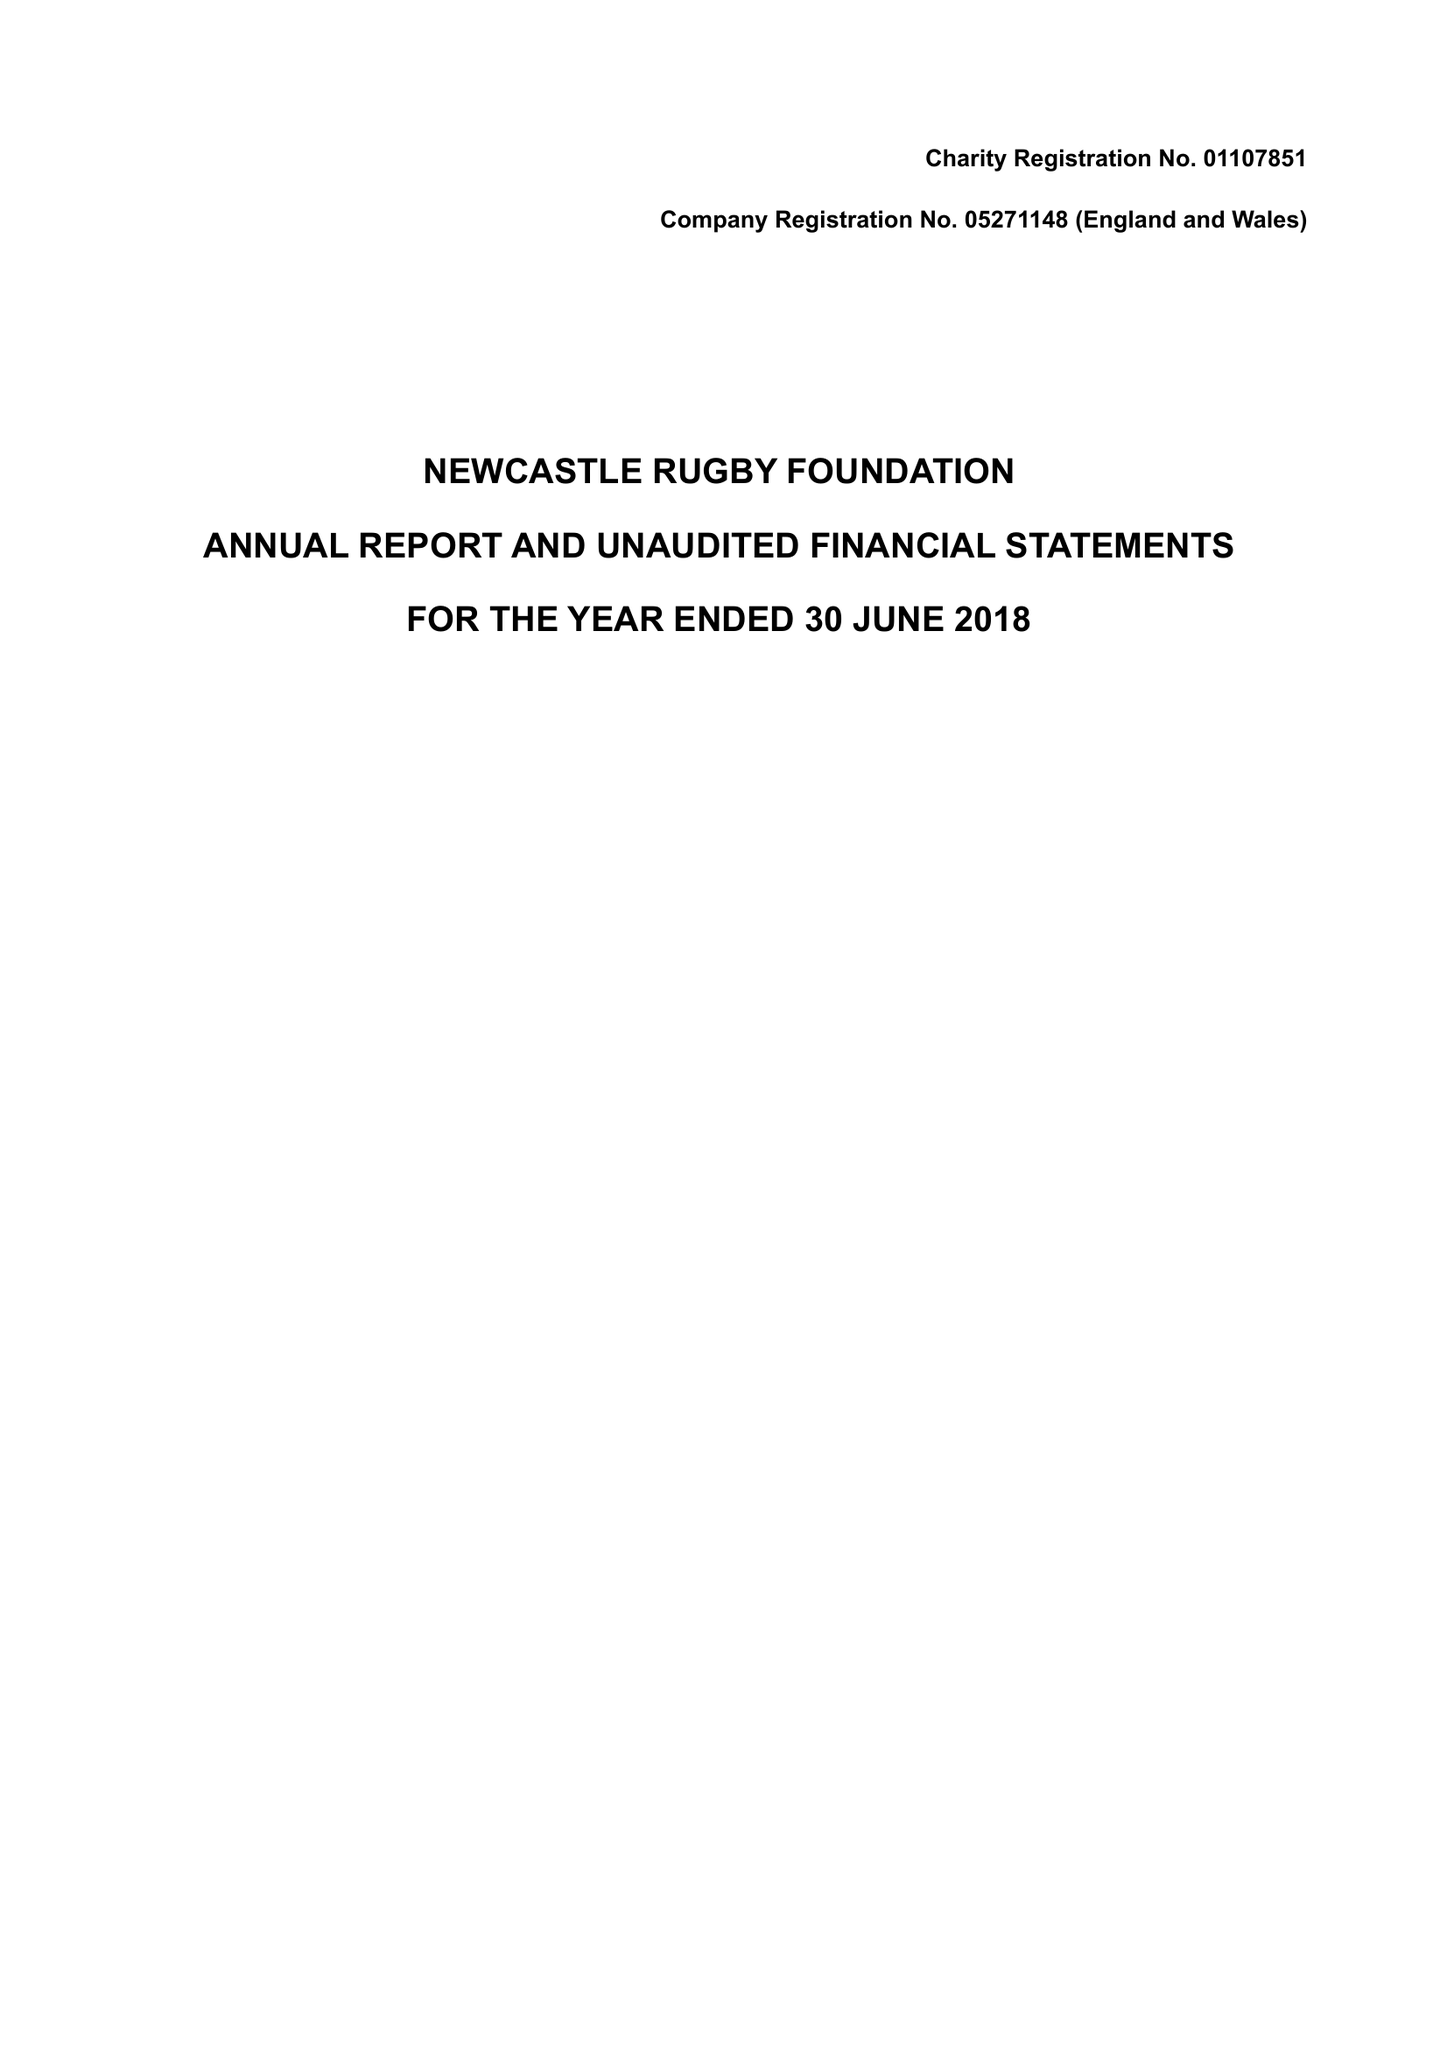What is the value for the address__post_town?
Answer the question using a single word or phrase. NEWCASTLE UPON TYNE 